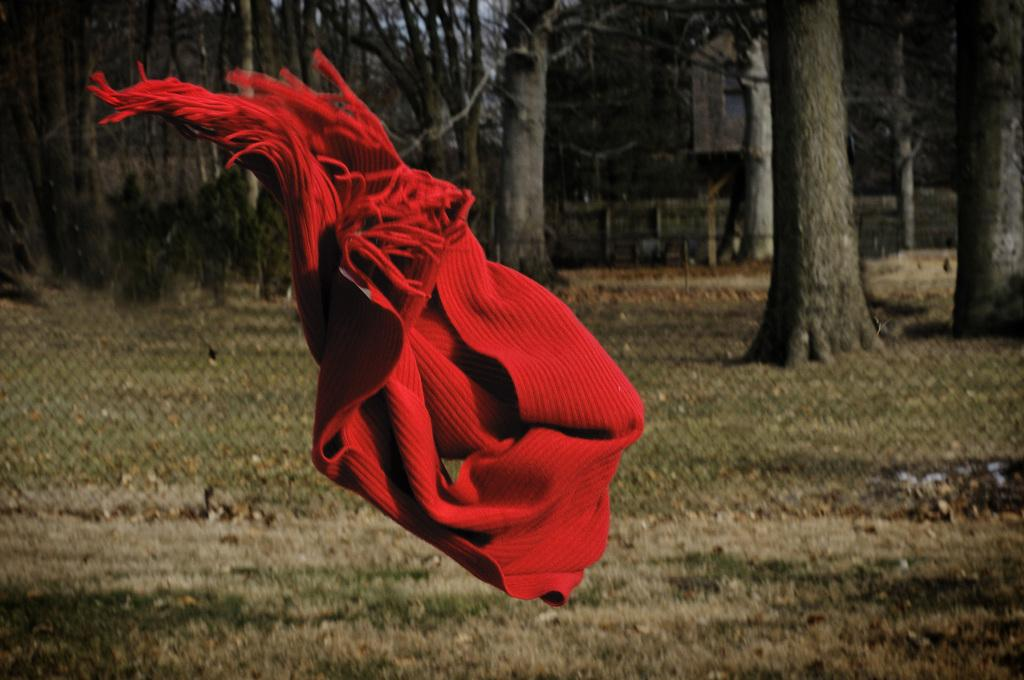What is flying in the air in the image? There is a scarf flying in the air in the image. What is located behind the flying scarf? There is a fence behind the scarf. What type of vegetation is present on the grassland in the image? There are trees on the grassland in the image. What can be seen in the background of the image? There is a building visible in the background of the image. What is the team's income from the tub in the image? There is no team or tub present in the image, so it is not possible to determine their income. 